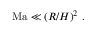Convert formula to latex. <formula><loc_0><loc_0><loc_500><loc_500>\begin{array} { r } { \ M a \ll ( R / H ) ^ { 2 } \ . \quad } \end{array}</formula> 